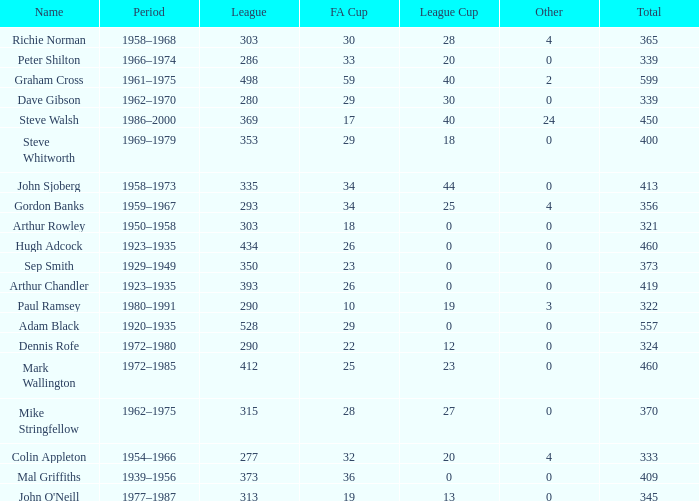What is the average number of FA cups Steve Whitworth, who has less than 400 total, has? None. 